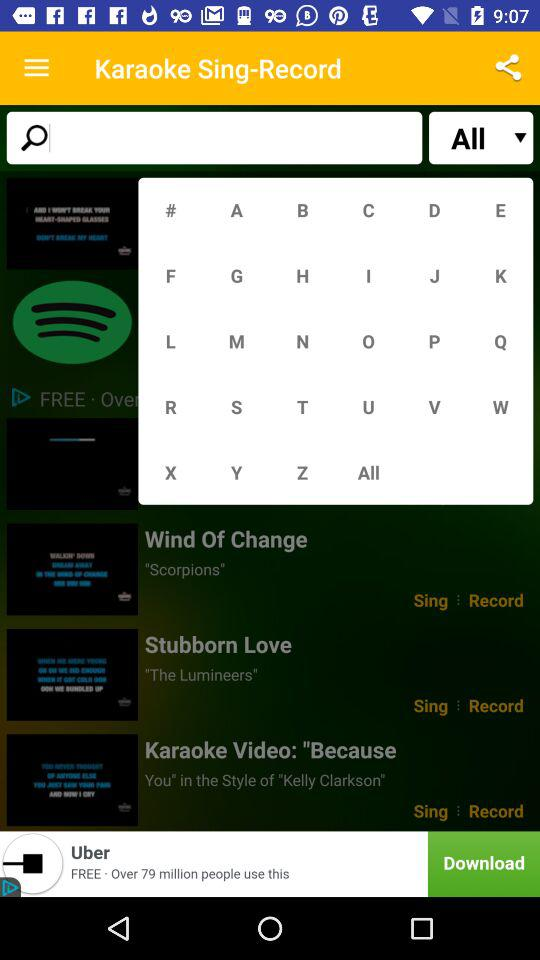What is the application name? The application name is "Karaoke Sing-Record". 